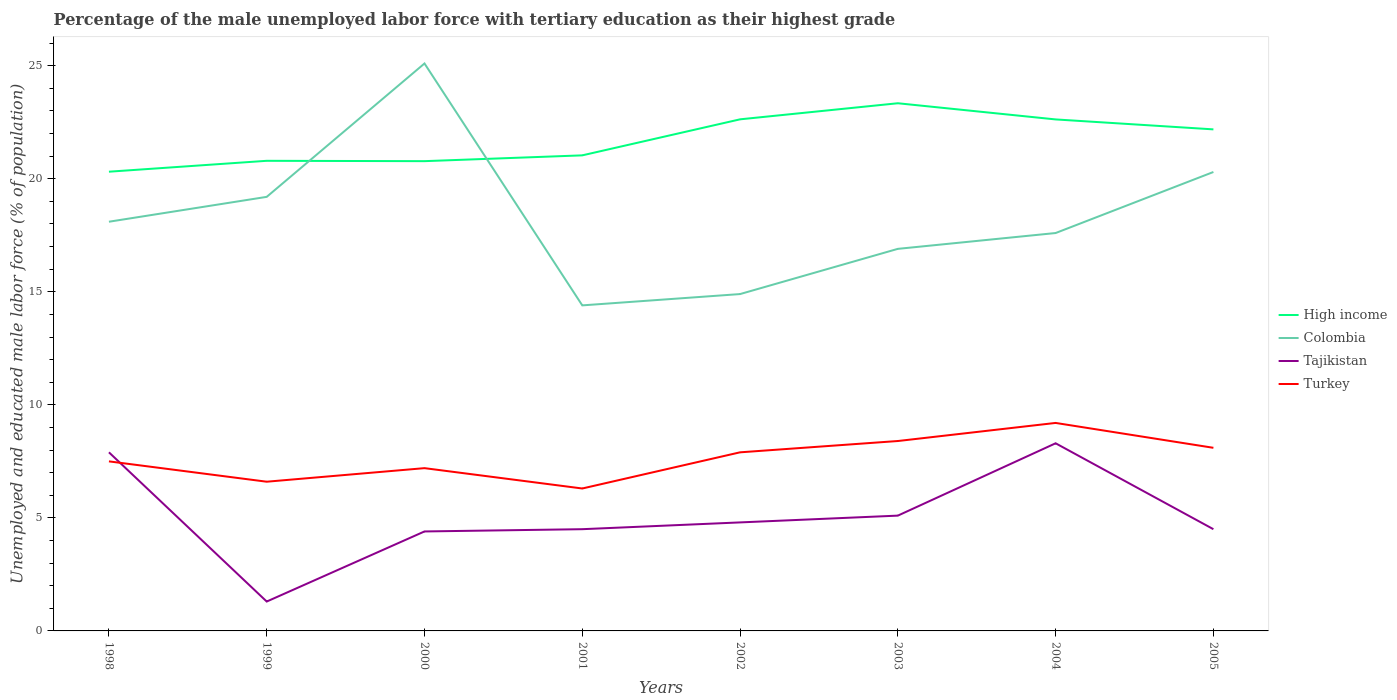How many different coloured lines are there?
Ensure brevity in your answer.  4. Does the line corresponding to Colombia intersect with the line corresponding to Turkey?
Ensure brevity in your answer.  No. Is the number of lines equal to the number of legend labels?
Offer a terse response. Yes. Across all years, what is the maximum percentage of the unemployed male labor force with tertiary education in Turkey?
Your answer should be very brief. 6.3. In which year was the percentage of the unemployed male labor force with tertiary education in High income maximum?
Your response must be concise. 1998. What is the total percentage of the unemployed male labor force with tertiary education in Colombia in the graph?
Keep it short and to the point. 0.5. What is the difference between the highest and the second highest percentage of the unemployed male labor force with tertiary education in Turkey?
Offer a very short reply. 2.9. What is the difference between the highest and the lowest percentage of the unemployed male labor force with tertiary education in Colombia?
Provide a short and direct response. 3. Is the percentage of the unemployed male labor force with tertiary education in High income strictly greater than the percentage of the unemployed male labor force with tertiary education in Colombia over the years?
Offer a terse response. No. How many lines are there?
Provide a short and direct response. 4. Does the graph contain any zero values?
Your response must be concise. No. Does the graph contain grids?
Your response must be concise. No. What is the title of the graph?
Give a very brief answer. Percentage of the male unemployed labor force with tertiary education as their highest grade. What is the label or title of the Y-axis?
Your answer should be compact. Unemployed and educated male labor force (% of population). What is the Unemployed and educated male labor force (% of population) in High income in 1998?
Make the answer very short. 20.31. What is the Unemployed and educated male labor force (% of population) of Colombia in 1998?
Offer a terse response. 18.1. What is the Unemployed and educated male labor force (% of population) of Tajikistan in 1998?
Offer a very short reply. 7.9. What is the Unemployed and educated male labor force (% of population) of High income in 1999?
Provide a succinct answer. 20.79. What is the Unemployed and educated male labor force (% of population) of Colombia in 1999?
Ensure brevity in your answer.  19.2. What is the Unemployed and educated male labor force (% of population) of Tajikistan in 1999?
Your response must be concise. 1.3. What is the Unemployed and educated male labor force (% of population) in Turkey in 1999?
Your answer should be very brief. 6.6. What is the Unemployed and educated male labor force (% of population) in High income in 2000?
Offer a terse response. 20.78. What is the Unemployed and educated male labor force (% of population) in Colombia in 2000?
Offer a terse response. 25.1. What is the Unemployed and educated male labor force (% of population) of Tajikistan in 2000?
Keep it short and to the point. 4.4. What is the Unemployed and educated male labor force (% of population) in Turkey in 2000?
Keep it short and to the point. 7.2. What is the Unemployed and educated male labor force (% of population) of High income in 2001?
Offer a terse response. 21.04. What is the Unemployed and educated male labor force (% of population) in Colombia in 2001?
Keep it short and to the point. 14.4. What is the Unemployed and educated male labor force (% of population) of Turkey in 2001?
Offer a very short reply. 6.3. What is the Unemployed and educated male labor force (% of population) of High income in 2002?
Your answer should be very brief. 22.63. What is the Unemployed and educated male labor force (% of population) of Colombia in 2002?
Give a very brief answer. 14.9. What is the Unemployed and educated male labor force (% of population) in Tajikistan in 2002?
Offer a terse response. 4.8. What is the Unemployed and educated male labor force (% of population) of Turkey in 2002?
Give a very brief answer. 7.9. What is the Unemployed and educated male labor force (% of population) of High income in 2003?
Your answer should be compact. 23.34. What is the Unemployed and educated male labor force (% of population) in Colombia in 2003?
Provide a short and direct response. 16.9. What is the Unemployed and educated male labor force (% of population) of Tajikistan in 2003?
Your response must be concise. 5.1. What is the Unemployed and educated male labor force (% of population) in Turkey in 2003?
Make the answer very short. 8.4. What is the Unemployed and educated male labor force (% of population) in High income in 2004?
Provide a short and direct response. 22.63. What is the Unemployed and educated male labor force (% of population) in Colombia in 2004?
Provide a short and direct response. 17.6. What is the Unemployed and educated male labor force (% of population) in Tajikistan in 2004?
Provide a short and direct response. 8.3. What is the Unemployed and educated male labor force (% of population) in Turkey in 2004?
Offer a terse response. 9.2. What is the Unemployed and educated male labor force (% of population) in High income in 2005?
Keep it short and to the point. 22.19. What is the Unemployed and educated male labor force (% of population) in Colombia in 2005?
Your response must be concise. 20.3. What is the Unemployed and educated male labor force (% of population) in Turkey in 2005?
Provide a short and direct response. 8.1. Across all years, what is the maximum Unemployed and educated male labor force (% of population) in High income?
Offer a very short reply. 23.34. Across all years, what is the maximum Unemployed and educated male labor force (% of population) of Colombia?
Make the answer very short. 25.1. Across all years, what is the maximum Unemployed and educated male labor force (% of population) in Tajikistan?
Offer a terse response. 8.3. Across all years, what is the maximum Unemployed and educated male labor force (% of population) of Turkey?
Ensure brevity in your answer.  9.2. Across all years, what is the minimum Unemployed and educated male labor force (% of population) of High income?
Offer a very short reply. 20.31. Across all years, what is the minimum Unemployed and educated male labor force (% of population) in Colombia?
Provide a short and direct response. 14.4. Across all years, what is the minimum Unemployed and educated male labor force (% of population) in Tajikistan?
Provide a succinct answer. 1.3. Across all years, what is the minimum Unemployed and educated male labor force (% of population) in Turkey?
Your answer should be very brief. 6.3. What is the total Unemployed and educated male labor force (% of population) of High income in the graph?
Your answer should be very brief. 173.7. What is the total Unemployed and educated male labor force (% of population) in Colombia in the graph?
Offer a terse response. 146.5. What is the total Unemployed and educated male labor force (% of population) in Tajikistan in the graph?
Offer a terse response. 40.8. What is the total Unemployed and educated male labor force (% of population) in Turkey in the graph?
Keep it short and to the point. 61.2. What is the difference between the Unemployed and educated male labor force (% of population) in High income in 1998 and that in 1999?
Make the answer very short. -0.48. What is the difference between the Unemployed and educated male labor force (% of population) in Colombia in 1998 and that in 1999?
Offer a terse response. -1.1. What is the difference between the Unemployed and educated male labor force (% of population) of High income in 1998 and that in 2000?
Keep it short and to the point. -0.47. What is the difference between the Unemployed and educated male labor force (% of population) in Colombia in 1998 and that in 2000?
Provide a succinct answer. -7. What is the difference between the Unemployed and educated male labor force (% of population) of High income in 1998 and that in 2001?
Provide a short and direct response. -0.72. What is the difference between the Unemployed and educated male labor force (% of population) in Colombia in 1998 and that in 2001?
Your answer should be compact. 3.7. What is the difference between the Unemployed and educated male labor force (% of population) in Tajikistan in 1998 and that in 2001?
Offer a terse response. 3.4. What is the difference between the Unemployed and educated male labor force (% of population) in High income in 1998 and that in 2002?
Your answer should be very brief. -2.32. What is the difference between the Unemployed and educated male labor force (% of population) of Colombia in 1998 and that in 2002?
Provide a succinct answer. 3.2. What is the difference between the Unemployed and educated male labor force (% of population) in Turkey in 1998 and that in 2002?
Offer a terse response. -0.4. What is the difference between the Unemployed and educated male labor force (% of population) of High income in 1998 and that in 2003?
Ensure brevity in your answer.  -3.03. What is the difference between the Unemployed and educated male labor force (% of population) of Tajikistan in 1998 and that in 2003?
Make the answer very short. 2.8. What is the difference between the Unemployed and educated male labor force (% of population) in Turkey in 1998 and that in 2003?
Your answer should be compact. -0.9. What is the difference between the Unemployed and educated male labor force (% of population) of High income in 1998 and that in 2004?
Your answer should be compact. -2.31. What is the difference between the Unemployed and educated male labor force (% of population) in High income in 1998 and that in 2005?
Offer a terse response. -1.87. What is the difference between the Unemployed and educated male labor force (% of population) of High income in 1999 and that in 2000?
Give a very brief answer. 0.02. What is the difference between the Unemployed and educated male labor force (% of population) of Colombia in 1999 and that in 2000?
Make the answer very short. -5.9. What is the difference between the Unemployed and educated male labor force (% of population) of Turkey in 1999 and that in 2000?
Provide a succinct answer. -0.6. What is the difference between the Unemployed and educated male labor force (% of population) in High income in 1999 and that in 2001?
Offer a very short reply. -0.24. What is the difference between the Unemployed and educated male labor force (% of population) of High income in 1999 and that in 2002?
Give a very brief answer. -1.83. What is the difference between the Unemployed and educated male labor force (% of population) in Colombia in 1999 and that in 2002?
Provide a short and direct response. 4.3. What is the difference between the Unemployed and educated male labor force (% of population) in High income in 1999 and that in 2003?
Your answer should be compact. -2.55. What is the difference between the Unemployed and educated male labor force (% of population) in Turkey in 1999 and that in 2003?
Give a very brief answer. -1.8. What is the difference between the Unemployed and educated male labor force (% of population) of High income in 1999 and that in 2004?
Ensure brevity in your answer.  -1.83. What is the difference between the Unemployed and educated male labor force (% of population) of Colombia in 1999 and that in 2004?
Ensure brevity in your answer.  1.6. What is the difference between the Unemployed and educated male labor force (% of population) in Tajikistan in 1999 and that in 2004?
Give a very brief answer. -7. What is the difference between the Unemployed and educated male labor force (% of population) in Turkey in 1999 and that in 2004?
Ensure brevity in your answer.  -2.6. What is the difference between the Unemployed and educated male labor force (% of population) in High income in 1999 and that in 2005?
Offer a very short reply. -1.39. What is the difference between the Unemployed and educated male labor force (% of population) in Tajikistan in 1999 and that in 2005?
Provide a short and direct response. -3.2. What is the difference between the Unemployed and educated male labor force (% of population) in High income in 2000 and that in 2001?
Provide a short and direct response. -0.26. What is the difference between the Unemployed and educated male labor force (% of population) in Tajikistan in 2000 and that in 2001?
Your response must be concise. -0.1. What is the difference between the Unemployed and educated male labor force (% of population) in High income in 2000 and that in 2002?
Give a very brief answer. -1.85. What is the difference between the Unemployed and educated male labor force (% of population) of Colombia in 2000 and that in 2002?
Provide a short and direct response. 10.2. What is the difference between the Unemployed and educated male labor force (% of population) of Tajikistan in 2000 and that in 2002?
Give a very brief answer. -0.4. What is the difference between the Unemployed and educated male labor force (% of population) in High income in 2000 and that in 2003?
Make the answer very short. -2.56. What is the difference between the Unemployed and educated male labor force (% of population) in Colombia in 2000 and that in 2003?
Provide a short and direct response. 8.2. What is the difference between the Unemployed and educated male labor force (% of population) in High income in 2000 and that in 2004?
Your answer should be compact. -1.85. What is the difference between the Unemployed and educated male labor force (% of population) of High income in 2000 and that in 2005?
Your answer should be compact. -1.41. What is the difference between the Unemployed and educated male labor force (% of population) of Colombia in 2000 and that in 2005?
Make the answer very short. 4.8. What is the difference between the Unemployed and educated male labor force (% of population) of Tajikistan in 2000 and that in 2005?
Offer a very short reply. -0.1. What is the difference between the Unemployed and educated male labor force (% of population) in Turkey in 2000 and that in 2005?
Your answer should be very brief. -0.9. What is the difference between the Unemployed and educated male labor force (% of population) in High income in 2001 and that in 2002?
Offer a very short reply. -1.59. What is the difference between the Unemployed and educated male labor force (% of population) in Tajikistan in 2001 and that in 2002?
Make the answer very short. -0.3. What is the difference between the Unemployed and educated male labor force (% of population) of High income in 2001 and that in 2003?
Give a very brief answer. -2.3. What is the difference between the Unemployed and educated male labor force (% of population) of Tajikistan in 2001 and that in 2003?
Make the answer very short. -0.6. What is the difference between the Unemployed and educated male labor force (% of population) of High income in 2001 and that in 2004?
Your answer should be very brief. -1.59. What is the difference between the Unemployed and educated male labor force (% of population) of Colombia in 2001 and that in 2004?
Keep it short and to the point. -3.2. What is the difference between the Unemployed and educated male labor force (% of population) in Tajikistan in 2001 and that in 2004?
Give a very brief answer. -3.8. What is the difference between the Unemployed and educated male labor force (% of population) of High income in 2001 and that in 2005?
Make the answer very short. -1.15. What is the difference between the Unemployed and educated male labor force (% of population) in Tajikistan in 2001 and that in 2005?
Offer a very short reply. 0. What is the difference between the Unemployed and educated male labor force (% of population) in High income in 2002 and that in 2003?
Give a very brief answer. -0.71. What is the difference between the Unemployed and educated male labor force (% of population) in High income in 2002 and that in 2004?
Your answer should be very brief. 0. What is the difference between the Unemployed and educated male labor force (% of population) in Colombia in 2002 and that in 2004?
Offer a very short reply. -2.7. What is the difference between the Unemployed and educated male labor force (% of population) of Tajikistan in 2002 and that in 2004?
Your answer should be very brief. -3.5. What is the difference between the Unemployed and educated male labor force (% of population) of High income in 2002 and that in 2005?
Offer a terse response. 0.44. What is the difference between the Unemployed and educated male labor force (% of population) of Tajikistan in 2002 and that in 2005?
Make the answer very short. 0.3. What is the difference between the Unemployed and educated male labor force (% of population) in Turkey in 2002 and that in 2005?
Offer a very short reply. -0.2. What is the difference between the Unemployed and educated male labor force (% of population) of High income in 2003 and that in 2004?
Ensure brevity in your answer.  0.72. What is the difference between the Unemployed and educated male labor force (% of population) of Tajikistan in 2003 and that in 2004?
Provide a short and direct response. -3.2. What is the difference between the Unemployed and educated male labor force (% of population) in High income in 2003 and that in 2005?
Offer a very short reply. 1.16. What is the difference between the Unemployed and educated male labor force (% of population) in Colombia in 2003 and that in 2005?
Provide a succinct answer. -3.4. What is the difference between the Unemployed and educated male labor force (% of population) in High income in 2004 and that in 2005?
Provide a succinct answer. 0.44. What is the difference between the Unemployed and educated male labor force (% of population) in Tajikistan in 2004 and that in 2005?
Ensure brevity in your answer.  3.8. What is the difference between the Unemployed and educated male labor force (% of population) in Turkey in 2004 and that in 2005?
Your answer should be very brief. 1.1. What is the difference between the Unemployed and educated male labor force (% of population) of High income in 1998 and the Unemployed and educated male labor force (% of population) of Colombia in 1999?
Give a very brief answer. 1.11. What is the difference between the Unemployed and educated male labor force (% of population) in High income in 1998 and the Unemployed and educated male labor force (% of population) in Tajikistan in 1999?
Your response must be concise. 19.01. What is the difference between the Unemployed and educated male labor force (% of population) in High income in 1998 and the Unemployed and educated male labor force (% of population) in Turkey in 1999?
Provide a short and direct response. 13.71. What is the difference between the Unemployed and educated male labor force (% of population) of High income in 1998 and the Unemployed and educated male labor force (% of population) of Colombia in 2000?
Offer a terse response. -4.79. What is the difference between the Unemployed and educated male labor force (% of population) of High income in 1998 and the Unemployed and educated male labor force (% of population) of Tajikistan in 2000?
Your answer should be very brief. 15.91. What is the difference between the Unemployed and educated male labor force (% of population) in High income in 1998 and the Unemployed and educated male labor force (% of population) in Turkey in 2000?
Ensure brevity in your answer.  13.11. What is the difference between the Unemployed and educated male labor force (% of population) of High income in 1998 and the Unemployed and educated male labor force (% of population) of Colombia in 2001?
Your answer should be very brief. 5.91. What is the difference between the Unemployed and educated male labor force (% of population) in High income in 1998 and the Unemployed and educated male labor force (% of population) in Tajikistan in 2001?
Make the answer very short. 15.81. What is the difference between the Unemployed and educated male labor force (% of population) of High income in 1998 and the Unemployed and educated male labor force (% of population) of Turkey in 2001?
Provide a succinct answer. 14.01. What is the difference between the Unemployed and educated male labor force (% of population) of Tajikistan in 1998 and the Unemployed and educated male labor force (% of population) of Turkey in 2001?
Provide a succinct answer. 1.6. What is the difference between the Unemployed and educated male labor force (% of population) of High income in 1998 and the Unemployed and educated male labor force (% of population) of Colombia in 2002?
Keep it short and to the point. 5.41. What is the difference between the Unemployed and educated male labor force (% of population) of High income in 1998 and the Unemployed and educated male labor force (% of population) of Tajikistan in 2002?
Offer a terse response. 15.51. What is the difference between the Unemployed and educated male labor force (% of population) of High income in 1998 and the Unemployed and educated male labor force (% of population) of Turkey in 2002?
Your response must be concise. 12.41. What is the difference between the Unemployed and educated male labor force (% of population) in Colombia in 1998 and the Unemployed and educated male labor force (% of population) in Tajikistan in 2002?
Give a very brief answer. 13.3. What is the difference between the Unemployed and educated male labor force (% of population) of Colombia in 1998 and the Unemployed and educated male labor force (% of population) of Turkey in 2002?
Your answer should be very brief. 10.2. What is the difference between the Unemployed and educated male labor force (% of population) of Tajikistan in 1998 and the Unemployed and educated male labor force (% of population) of Turkey in 2002?
Offer a terse response. 0. What is the difference between the Unemployed and educated male labor force (% of population) in High income in 1998 and the Unemployed and educated male labor force (% of population) in Colombia in 2003?
Offer a very short reply. 3.41. What is the difference between the Unemployed and educated male labor force (% of population) of High income in 1998 and the Unemployed and educated male labor force (% of population) of Tajikistan in 2003?
Provide a succinct answer. 15.21. What is the difference between the Unemployed and educated male labor force (% of population) in High income in 1998 and the Unemployed and educated male labor force (% of population) in Turkey in 2003?
Make the answer very short. 11.91. What is the difference between the Unemployed and educated male labor force (% of population) of Colombia in 1998 and the Unemployed and educated male labor force (% of population) of Turkey in 2003?
Your answer should be compact. 9.7. What is the difference between the Unemployed and educated male labor force (% of population) of Tajikistan in 1998 and the Unemployed and educated male labor force (% of population) of Turkey in 2003?
Make the answer very short. -0.5. What is the difference between the Unemployed and educated male labor force (% of population) in High income in 1998 and the Unemployed and educated male labor force (% of population) in Colombia in 2004?
Offer a terse response. 2.71. What is the difference between the Unemployed and educated male labor force (% of population) of High income in 1998 and the Unemployed and educated male labor force (% of population) of Tajikistan in 2004?
Offer a terse response. 12.01. What is the difference between the Unemployed and educated male labor force (% of population) of High income in 1998 and the Unemployed and educated male labor force (% of population) of Turkey in 2004?
Provide a succinct answer. 11.11. What is the difference between the Unemployed and educated male labor force (% of population) in Colombia in 1998 and the Unemployed and educated male labor force (% of population) in Tajikistan in 2004?
Provide a succinct answer. 9.8. What is the difference between the Unemployed and educated male labor force (% of population) in High income in 1998 and the Unemployed and educated male labor force (% of population) in Colombia in 2005?
Your answer should be compact. 0.01. What is the difference between the Unemployed and educated male labor force (% of population) in High income in 1998 and the Unemployed and educated male labor force (% of population) in Tajikistan in 2005?
Your response must be concise. 15.81. What is the difference between the Unemployed and educated male labor force (% of population) in High income in 1998 and the Unemployed and educated male labor force (% of population) in Turkey in 2005?
Your response must be concise. 12.21. What is the difference between the Unemployed and educated male labor force (% of population) in Colombia in 1998 and the Unemployed and educated male labor force (% of population) in Tajikistan in 2005?
Your answer should be very brief. 13.6. What is the difference between the Unemployed and educated male labor force (% of population) in Colombia in 1998 and the Unemployed and educated male labor force (% of population) in Turkey in 2005?
Give a very brief answer. 10. What is the difference between the Unemployed and educated male labor force (% of population) in High income in 1999 and the Unemployed and educated male labor force (% of population) in Colombia in 2000?
Your answer should be very brief. -4.31. What is the difference between the Unemployed and educated male labor force (% of population) in High income in 1999 and the Unemployed and educated male labor force (% of population) in Tajikistan in 2000?
Give a very brief answer. 16.39. What is the difference between the Unemployed and educated male labor force (% of population) of High income in 1999 and the Unemployed and educated male labor force (% of population) of Turkey in 2000?
Provide a succinct answer. 13.59. What is the difference between the Unemployed and educated male labor force (% of population) in Colombia in 1999 and the Unemployed and educated male labor force (% of population) in Tajikistan in 2000?
Provide a short and direct response. 14.8. What is the difference between the Unemployed and educated male labor force (% of population) in Tajikistan in 1999 and the Unemployed and educated male labor force (% of population) in Turkey in 2000?
Keep it short and to the point. -5.9. What is the difference between the Unemployed and educated male labor force (% of population) of High income in 1999 and the Unemployed and educated male labor force (% of population) of Colombia in 2001?
Your answer should be compact. 6.39. What is the difference between the Unemployed and educated male labor force (% of population) in High income in 1999 and the Unemployed and educated male labor force (% of population) in Tajikistan in 2001?
Your response must be concise. 16.29. What is the difference between the Unemployed and educated male labor force (% of population) of High income in 1999 and the Unemployed and educated male labor force (% of population) of Turkey in 2001?
Your answer should be compact. 14.49. What is the difference between the Unemployed and educated male labor force (% of population) of High income in 1999 and the Unemployed and educated male labor force (% of population) of Colombia in 2002?
Offer a terse response. 5.89. What is the difference between the Unemployed and educated male labor force (% of population) in High income in 1999 and the Unemployed and educated male labor force (% of population) in Tajikistan in 2002?
Your answer should be very brief. 15.99. What is the difference between the Unemployed and educated male labor force (% of population) of High income in 1999 and the Unemployed and educated male labor force (% of population) of Turkey in 2002?
Your response must be concise. 12.89. What is the difference between the Unemployed and educated male labor force (% of population) of Colombia in 1999 and the Unemployed and educated male labor force (% of population) of Turkey in 2002?
Offer a very short reply. 11.3. What is the difference between the Unemployed and educated male labor force (% of population) of Tajikistan in 1999 and the Unemployed and educated male labor force (% of population) of Turkey in 2002?
Your answer should be compact. -6.6. What is the difference between the Unemployed and educated male labor force (% of population) in High income in 1999 and the Unemployed and educated male labor force (% of population) in Colombia in 2003?
Your answer should be very brief. 3.89. What is the difference between the Unemployed and educated male labor force (% of population) in High income in 1999 and the Unemployed and educated male labor force (% of population) in Tajikistan in 2003?
Give a very brief answer. 15.69. What is the difference between the Unemployed and educated male labor force (% of population) in High income in 1999 and the Unemployed and educated male labor force (% of population) in Turkey in 2003?
Give a very brief answer. 12.39. What is the difference between the Unemployed and educated male labor force (% of population) in Colombia in 1999 and the Unemployed and educated male labor force (% of population) in Tajikistan in 2003?
Offer a very short reply. 14.1. What is the difference between the Unemployed and educated male labor force (% of population) of Colombia in 1999 and the Unemployed and educated male labor force (% of population) of Turkey in 2003?
Your response must be concise. 10.8. What is the difference between the Unemployed and educated male labor force (% of population) of Tajikistan in 1999 and the Unemployed and educated male labor force (% of population) of Turkey in 2003?
Your response must be concise. -7.1. What is the difference between the Unemployed and educated male labor force (% of population) in High income in 1999 and the Unemployed and educated male labor force (% of population) in Colombia in 2004?
Your response must be concise. 3.19. What is the difference between the Unemployed and educated male labor force (% of population) in High income in 1999 and the Unemployed and educated male labor force (% of population) in Tajikistan in 2004?
Your answer should be compact. 12.49. What is the difference between the Unemployed and educated male labor force (% of population) in High income in 1999 and the Unemployed and educated male labor force (% of population) in Turkey in 2004?
Offer a terse response. 11.59. What is the difference between the Unemployed and educated male labor force (% of population) of Colombia in 1999 and the Unemployed and educated male labor force (% of population) of Tajikistan in 2004?
Your answer should be compact. 10.9. What is the difference between the Unemployed and educated male labor force (% of population) in Colombia in 1999 and the Unemployed and educated male labor force (% of population) in Turkey in 2004?
Your response must be concise. 10. What is the difference between the Unemployed and educated male labor force (% of population) of High income in 1999 and the Unemployed and educated male labor force (% of population) of Colombia in 2005?
Provide a succinct answer. 0.49. What is the difference between the Unemployed and educated male labor force (% of population) in High income in 1999 and the Unemployed and educated male labor force (% of population) in Tajikistan in 2005?
Your response must be concise. 16.29. What is the difference between the Unemployed and educated male labor force (% of population) of High income in 1999 and the Unemployed and educated male labor force (% of population) of Turkey in 2005?
Provide a short and direct response. 12.69. What is the difference between the Unemployed and educated male labor force (% of population) in Colombia in 1999 and the Unemployed and educated male labor force (% of population) in Tajikistan in 2005?
Give a very brief answer. 14.7. What is the difference between the Unemployed and educated male labor force (% of population) of High income in 2000 and the Unemployed and educated male labor force (% of population) of Colombia in 2001?
Offer a very short reply. 6.38. What is the difference between the Unemployed and educated male labor force (% of population) in High income in 2000 and the Unemployed and educated male labor force (% of population) in Tajikistan in 2001?
Offer a terse response. 16.28. What is the difference between the Unemployed and educated male labor force (% of population) in High income in 2000 and the Unemployed and educated male labor force (% of population) in Turkey in 2001?
Give a very brief answer. 14.48. What is the difference between the Unemployed and educated male labor force (% of population) in Colombia in 2000 and the Unemployed and educated male labor force (% of population) in Tajikistan in 2001?
Your answer should be very brief. 20.6. What is the difference between the Unemployed and educated male labor force (% of population) of Colombia in 2000 and the Unemployed and educated male labor force (% of population) of Turkey in 2001?
Ensure brevity in your answer.  18.8. What is the difference between the Unemployed and educated male labor force (% of population) of Tajikistan in 2000 and the Unemployed and educated male labor force (% of population) of Turkey in 2001?
Your response must be concise. -1.9. What is the difference between the Unemployed and educated male labor force (% of population) in High income in 2000 and the Unemployed and educated male labor force (% of population) in Colombia in 2002?
Ensure brevity in your answer.  5.88. What is the difference between the Unemployed and educated male labor force (% of population) in High income in 2000 and the Unemployed and educated male labor force (% of population) in Tajikistan in 2002?
Your answer should be compact. 15.98. What is the difference between the Unemployed and educated male labor force (% of population) of High income in 2000 and the Unemployed and educated male labor force (% of population) of Turkey in 2002?
Your response must be concise. 12.88. What is the difference between the Unemployed and educated male labor force (% of population) in Colombia in 2000 and the Unemployed and educated male labor force (% of population) in Tajikistan in 2002?
Provide a succinct answer. 20.3. What is the difference between the Unemployed and educated male labor force (% of population) in High income in 2000 and the Unemployed and educated male labor force (% of population) in Colombia in 2003?
Give a very brief answer. 3.88. What is the difference between the Unemployed and educated male labor force (% of population) in High income in 2000 and the Unemployed and educated male labor force (% of population) in Tajikistan in 2003?
Provide a succinct answer. 15.68. What is the difference between the Unemployed and educated male labor force (% of population) in High income in 2000 and the Unemployed and educated male labor force (% of population) in Turkey in 2003?
Give a very brief answer. 12.38. What is the difference between the Unemployed and educated male labor force (% of population) of Colombia in 2000 and the Unemployed and educated male labor force (% of population) of Tajikistan in 2003?
Your answer should be compact. 20. What is the difference between the Unemployed and educated male labor force (% of population) of Colombia in 2000 and the Unemployed and educated male labor force (% of population) of Turkey in 2003?
Your answer should be very brief. 16.7. What is the difference between the Unemployed and educated male labor force (% of population) of High income in 2000 and the Unemployed and educated male labor force (% of population) of Colombia in 2004?
Your response must be concise. 3.18. What is the difference between the Unemployed and educated male labor force (% of population) in High income in 2000 and the Unemployed and educated male labor force (% of population) in Tajikistan in 2004?
Your answer should be very brief. 12.48. What is the difference between the Unemployed and educated male labor force (% of population) in High income in 2000 and the Unemployed and educated male labor force (% of population) in Turkey in 2004?
Give a very brief answer. 11.58. What is the difference between the Unemployed and educated male labor force (% of population) of Colombia in 2000 and the Unemployed and educated male labor force (% of population) of Tajikistan in 2004?
Your response must be concise. 16.8. What is the difference between the Unemployed and educated male labor force (% of population) in Colombia in 2000 and the Unemployed and educated male labor force (% of population) in Turkey in 2004?
Your answer should be compact. 15.9. What is the difference between the Unemployed and educated male labor force (% of population) of High income in 2000 and the Unemployed and educated male labor force (% of population) of Colombia in 2005?
Offer a very short reply. 0.48. What is the difference between the Unemployed and educated male labor force (% of population) of High income in 2000 and the Unemployed and educated male labor force (% of population) of Tajikistan in 2005?
Keep it short and to the point. 16.28. What is the difference between the Unemployed and educated male labor force (% of population) of High income in 2000 and the Unemployed and educated male labor force (% of population) of Turkey in 2005?
Your response must be concise. 12.68. What is the difference between the Unemployed and educated male labor force (% of population) in Colombia in 2000 and the Unemployed and educated male labor force (% of population) in Tajikistan in 2005?
Your answer should be very brief. 20.6. What is the difference between the Unemployed and educated male labor force (% of population) of Colombia in 2000 and the Unemployed and educated male labor force (% of population) of Turkey in 2005?
Your response must be concise. 17. What is the difference between the Unemployed and educated male labor force (% of population) in Tajikistan in 2000 and the Unemployed and educated male labor force (% of population) in Turkey in 2005?
Ensure brevity in your answer.  -3.7. What is the difference between the Unemployed and educated male labor force (% of population) in High income in 2001 and the Unemployed and educated male labor force (% of population) in Colombia in 2002?
Give a very brief answer. 6.14. What is the difference between the Unemployed and educated male labor force (% of population) of High income in 2001 and the Unemployed and educated male labor force (% of population) of Tajikistan in 2002?
Your answer should be compact. 16.24. What is the difference between the Unemployed and educated male labor force (% of population) of High income in 2001 and the Unemployed and educated male labor force (% of population) of Turkey in 2002?
Provide a succinct answer. 13.14. What is the difference between the Unemployed and educated male labor force (% of population) of High income in 2001 and the Unemployed and educated male labor force (% of population) of Colombia in 2003?
Provide a succinct answer. 4.14. What is the difference between the Unemployed and educated male labor force (% of population) of High income in 2001 and the Unemployed and educated male labor force (% of population) of Tajikistan in 2003?
Your answer should be compact. 15.94. What is the difference between the Unemployed and educated male labor force (% of population) of High income in 2001 and the Unemployed and educated male labor force (% of population) of Turkey in 2003?
Your answer should be very brief. 12.64. What is the difference between the Unemployed and educated male labor force (% of population) in Colombia in 2001 and the Unemployed and educated male labor force (% of population) in Turkey in 2003?
Your response must be concise. 6. What is the difference between the Unemployed and educated male labor force (% of population) of Tajikistan in 2001 and the Unemployed and educated male labor force (% of population) of Turkey in 2003?
Your response must be concise. -3.9. What is the difference between the Unemployed and educated male labor force (% of population) in High income in 2001 and the Unemployed and educated male labor force (% of population) in Colombia in 2004?
Make the answer very short. 3.44. What is the difference between the Unemployed and educated male labor force (% of population) in High income in 2001 and the Unemployed and educated male labor force (% of population) in Tajikistan in 2004?
Offer a terse response. 12.74. What is the difference between the Unemployed and educated male labor force (% of population) in High income in 2001 and the Unemployed and educated male labor force (% of population) in Turkey in 2004?
Offer a terse response. 11.84. What is the difference between the Unemployed and educated male labor force (% of population) of High income in 2001 and the Unemployed and educated male labor force (% of population) of Colombia in 2005?
Your answer should be very brief. 0.74. What is the difference between the Unemployed and educated male labor force (% of population) of High income in 2001 and the Unemployed and educated male labor force (% of population) of Tajikistan in 2005?
Provide a short and direct response. 16.54. What is the difference between the Unemployed and educated male labor force (% of population) in High income in 2001 and the Unemployed and educated male labor force (% of population) in Turkey in 2005?
Offer a very short reply. 12.94. What is the difference between the Unemployed and educated male labor force (% of population) in Tajikistan in 2001 and the Unemployed and educated male labor force (% of population) in Turkey in 2005?
Offer a very short reply. -3.6. What is the difference between the Unemployed and educated male labor force (% of population) in High income in 2002 and the Unemployed and educated male labor force (% of population) in Colombia in 2003?
Give a very brief answer. 5.73. What is the difference between the Unemployed and educated male labor force (% of population) in High income in 2002 and the Unemployed and educated male labor force (% of population) in Tajikistan in 2003?
Offer a terse response. 17.53. What is the difference between the Unemployed and educated male labor force (% of population) of High income in 2002 and the Unemployed and educated male labor force (% of population) of Turkey in 2003?
Provide a short and direct response. 14.23. What is the difference between the Unemployed and educated male labor force (% of population) in Colombia in 2002 and the Unemployed and educated male labor force (% of population) in Turkey in 2003?
Provide a short and direct response. 6.5. What is the difference between the Unemployed and educated male labor force (% of population) of Tajikistan in 2002 and the Unemployed and educated male labor force (% of population) of Turkey in 2003?
Provide a short and direct response. -3.6. What is the difference between the Unemployed and educated male labor force (% of population) of High income in 2002 and the Unemployed and educated male labor force (% of population) of Colombia in 2004?
Make the answer very short. 5.03. What is the difference between the Unemployed and educated male labor force (% of population) of High income in 2002 and the Unemployed and educated male labor force (% of population) of Tajikistan in 2004?
Your answer should be very brief. 14.33. What is the difference between the Unemployed and educated male labor force (% of population) of High income in 2002 and the Unemployed and educated male labor force (% of population) of Turkey in 2004?
Ensure brevity in your answer.  13.43. What is the difference between the Unemployed and educated male labor force (% of population) of Colombia in 2002 and the Unemployed and educated male labor force (% of population) of Tajikistan in 2004?
Make the answer very short. 6.6. What is the difference between the Unemployed and educated male labor force (% of population) of Colombia in 2002 and the Unemployed and educated male labor force (% of population) of Turkey in 2004?
Your answer should be compact. 5.7. What is the difference between the Unemployed and educated male labor force (% of population) in High income in 2002 and the Unemployed and educated male labor force (% of population) in Colombia in 2005?
Offer a very short reply. 2.33. What is the difference between the Unemployed and educated male labor force (% of population) in High income in 2002 and the Unemployed and educated male labor force (% of population) in Tajikistan in 2005?
Offer a very short reply. 18.13. What is the difference between the Unemployed and educated male labor force (% of population) of High income in 2002 and the Unemployed and educated male labor force (% of population) of Turkey in 2005?
Provide a short and direct response. 14.53. What is the difference between the Unemployed and educated male labor force (% of population) of Colombia in 2002 and the Unemployed and educated male labor force (% of population) of Tajikistan in 2005?
Your answer should be very brief. 10.4. What is the difference between the Unemployed and educated male labor force (% of population) of High income in 2003 and the Unemployed and educated male labor force (% of population) of Colombia in 2004?
Provide a short and direct response. 5.74. What is the difference between the Unemployed and educated male labor force (% of population) in High income in 2003 and the Unemployed and educated male labor force (% of population) in Tajikistan in 2004?
Ensure brevity in your answer.  15.04. What is the difference between the Unemployed and educated male labor force (% of population) of High income in 2003 and the Unemployed and educated male labor force (% of population) of Turkey in 2004?
Offer a very short reply. 14.14. What is the difference between the Unemployed and educated male labor force (% of population) of Colombia in 2003 and the Unemployed and educated male labor force (% of population) of Tajikistan in 2004?
Keep it short and to the point. 8.6. What is the difference between the Unemployed and educated male labor force (% of population) in Colombia in 2003 and the Unemployed and educated male labor force (% of population) in Turkey in 2004?
Ensure brevity in your answer.  7.7. What is the difference between the Unemployed and educated male labor force (% of population) of High income in 2003 and the Unemployed and educated male labor force (% of population) of Colombia in 2005?
Your answer should be very brief. 3.04. What is the difference between the Unemployed and educated male labor force (% of population) in High income in 2003 and the Unemployed and educated male labor force (% of population) in Tajikistan in 2005?
Provide a succinct answer. 18.84. What is the difference between the Unemployed and educated male labor force (% of population) in High income in 2003 and the Unemployed and educated male labor force (% of population) in Turkey in 2005?
Ensure brevity in your answer.  15.24. What is the difference between the Unemployed and educated male labor force (% of population) of Colombia in 2003 and the Unemployed and educated male labor force (% of population) of Turkey in 2005?
Offer a terse response. 8.8. What is the difference between the Unemployed and educated male labor force (% of population) in Tajikistan in 2003 and the Unemployed and educated male labor force (% of population) in Turkey in 2005?
Offer a terse response. -3. What is the difference between the Unemployed and educated male labor force (% of population) of High income in 2004 and the Unemployed and educated male labor force (% of population) of Colombia in 2005?
Ensure brevity in your answer.  2.33. What is the difference between the Unemployed and educated male labor force (% of population) of High income in 2004 and the Unemployed and educated male labor force (% of population) of Tajikistan in 2005?
Offer a terse response. 18.13. What is the difference between the Unemployed and educated male labor force (% of population) of High income in 2004 and the Unemployed and educated male labor force (% of population) of Turkey in 2005?
Your answer should be compact. 14.53. What is the difference between the Unemployed and educated male labor force (% of population) in Tajikistan in 2004 and the Unemployed and educated male labor force (% of population) in Turkey in 2005?
Your answer should be very brief. 0.2. What is the average Unemployed and educated male labor force (% of population) of High income per year?
Offer a very short reply. 21.71. What is the average Unemployed and educated male labor force (% of population) of Colombia per year?
Ensure brevity in your answer.  18.31. What is the average Unemployed and educated male labor force (% of population) of Tajikistan per year?
Your response must be concise. 5.1. What is the average Unemployed and educated male labor force (% of population) in Turkey per year?
Your response must be concise. 7.65. In the year 1998, what is the difference between the Unemployed and educated male labor force (% of population) in High income and Unemployed and educated male labor force (% of population) in Colombia?
Make the answer very short. 2.21. In the year 1998, what is the difference between the Unemployed and educated male labor force (% of population) of High income and Unemployed and educated male labor force (% of population) of Tajikistan?
Keep it short and to the point. 12.41. In the year 1998, what is the difference between the Unemployed and educated male labor force (% of population) in High income and Unemployed and educated male labor force (% of population) in Turkey?
Make the answer very short. 12.81. In the year 1998, what is the difference between the Unemployed and educated male labor force (% of population) of Colombia and Unemployed and educated male labor force (% of population) of Turkey?
Give a very brief answer. 10.6. In the year 1999, what is the difference between the Unemployed and educated male labor force (% of population) of High income and Unemployed and educated male labor force (% of population) of Colombia?
Make the answer very short. 1.59. In the year 1999, what is the difference between the Unemployed and educated male labor force (% of population) in High income and Unemployed and educated male labor force (% of population) in Tajikistan?
Your answer should be very brief. 19.49. In the year 1999, what is the difference between the Unemployed and educated male labor force (% of population) in High income and Unemployed and educated male labor force (% of population) in Turkey?
Provide a short and direct response. 14.19. In the year 1999, what is the difference between the Unemployed and educated male labor force (% of population) in Colombia and Unemployed and educated male labor force (% of population) in Turkey?
Provide a succinct answer. 12.6. In the year 2000, what is the difference between the Unemployed and educated male labor force (% of population) in High income and Unemployed and educated male labor force (% of population) in Colombia?
Your answer should be very brief. -4.32. In the year 2000, what is the difference between the Unemployed and educated male labor force (% of population) in High income and Unemployed and educated male labor force (% of population) in Tajikistan?
Your answer should be very brief. 16.38. In the year 2000, what is the difference between the Unemployed and educated male labor force (% of population) of High income and Unemployed and educated male labor force (% of population) of Turkey?
Offer a terse response. 13.58. In the year 2000, what is the difference between the Unemployed and educated male labor force (% of population) of Colombia and Unemployed and educated male labor force (% of population) of Tajikistan?
Make the answer very short. 20.7. In the year 2001, what is the difference between the Unemployed and educated male labor force (% of population) in High income and Unemployed and educated male labor force (% of population) in Colombia?
Ensure brevity in your answer.  6.64. In the year 2001, what is the difference between the Unemployed and educated male labor force (% of population) in High income and Unemployed and educated male labor force (% of population) in Tajikistan?
Ensure brevity in your answer.  16.54. In the year 2001, what is the difference between the Unemployed and educated male labor force (% of population) in High income and Unemployed and educated male labor force (% of population) in Turkey?
Provide a short and direct response. 14.74. In the year 2002, what is the difference between the Unemployed and educated male labor force (% of population) in High income and Unemployed and educated male labor force (% of population) in Colombia?
Offer a terse response. 7.73. In the year 2002, what is the difference between the Unemployed and educated male labor force (% of population) of High income and Unemployed and educated male labor force (% of population) of Tajikistan?
Your response must be concise. 17.83. In the year 2002, what is the difference between the Unemployed and educated male labor force (% of population) in High income and Unemployed and educated male labor force (% of population) in Turkey?
Ensure brevity in your answer.  14.73. In the year 2002, what is the difference between the Unemployed and educated male labor force (% of population) in Colombia and Unemployed and educated male labor force (% of population) in Turkey?
Your answer should be very brief. 7. In the year 2002, what is the difference between the Unemployed and educated male labor force (% of population) in Tajikistan and Unemployed and educated male labor force (% of population) in Turkey?
Provide a succinct answer. -3.1. In the year 2003, what is the difference between the Unemployed and educated male labor force (% of population) in High income and Unemployed and educated male labor force (% of population) in Colombia?
Your answer should be compact. 6.44. In the year 2003, what is the difference between the Unemployed and educated male labor force (% of population) of High income and Unemployed and educated male labor force (% of population) of Tajikistan?
Keep it short and to the point. 18.24. In the year 2003, what is the difference between the Unemployed and educated male labor force (% of population) of High income and Unemployed and educated male labor force (% of population) of Turkey?
Provide a short and direct response. 14.94. In the year 2003, what is the difference between the Unemployed and educated male labor force (% of population) of Tajikistan and Unemployed and educated male labor force (% of population) of Turkey?
Your response must be concise. -3.3. In the year 2004, what is the difference between the Unemployed and educated male labor force (% of population) in High income and Unemployed and educated male labor force (% of population) in Colombia?
Ensure brevity in your answer.  5.03. In the year 2004, what is the difference between the Unemployed and educated male labor force (% of population) of High income and Unemployed and educated male labor force (% of population) of Tajikistan?
Keep it short and to the point. 14.33. In the year 2004, what is the difference between the Unemployed and educated male labor force (% of population) of High income and Unemployed and educated male labor force (% of population) of Turkey?
Provide a succinct answer. 13.43. In the year 2004, what is the difference between the Unemployed and educated male labor force (% of population) in Colombia and Unemployed and educated male labor force (% of population) in Turkey?
Offer a very short reply. 8.4. In the year 2005, what is the difference between the Unemployed and educated male labor force (% of population) of High income and Unemployed and educated male labor force (% of population) of Colombia?
Ensure brevity in your answer.  1.89. In the year 2005, what is the difference between the Unemployed and educated male labor force (% of population) in High income and Unemployed and educated male labor force (% of population) in Tajikistan?
Give a very brief answer. 17.68. In the year 2005, what is the difference between the Unemployed and educated male labor force (% of population) of High income and Unemployed and educated male labor force (% of population) of Turkey?
Ensure brevity in your answer.  14.09. In the year 2005, what is the difference between the Unemployed and educated male labor force (% of population) of Tajikistan and Unemployed and educated male labor force (% of population) of Turkey?
Your answer should be very brief. -3.6. What is the ratio of the Unemployed and educated male labor force (% of population) of High income in 1998 to that in 1999?
Keep it short and to the point. 0.98. What is the ratio of the Unemployed and educated male labor force (% of population) of Colombia in 1998 to that in 1999?
Provide a short and direct response. 0.94. What is the ratio of the Unemployed and educated male labor force (% of population) in Tajikistan in 1998 to that in 1999?
Offer a terse response. 6.08. What is the ratio of the Unemployed and educated male labor force (% of population) of Turkey in 1998 to that in 1999?
Give a very brief answer. 1.14. What is the ratio of the Unemployed and educated male labor force (% of population) in High income in 1998 to that in 2000?
Give a very brief answer. 0.98. What is the ratio of the Unemployed and educated male labor force (% of population) of Colombia in 1998 to that in 2000?
Make the answer very short. 0.72. What is the ratio of the Unemployed and educated male labor force (% of population) in Tajikistan in 1998 to that in 2000?
Offer a very short reply. 1.8. What is the ratio of the Unemployed and educated male labor force (% of population) in Turkey in 1998 to that in 2000?
Provide a succinct answer. 1.04. What is the ratio of the Unemployed and educated male labor force (% of population) in High income in 1998 to that in 2001?
Provide a succinct answer. 0.97. What is the ratio of the Unemployed and educated male labor force (% of population) of Colombia in 1998 to that in 2001?
Keep it short and to the point. 1.26. What is the ratio of the Unemployed and educated male labor force (% of population) in Tajikistan in 1998 to that in 2001?
Provide a short and direct response. 1.76. What is the ratio of the Unemployed and educated male labor force (% of population) of Turkey in 1998 to that in 2001?
Your response must be concise. 1.19. What is the ratio of the Unemployed and educated male labor force (% of population) in High income in 1998 to that in 2002?
Offer a terse response. 0.9. What is the ratio of the Unemployed and educated male labor force (% of population) of Colombia in 1998 to that in 2002?
Provide a succinct answer. 1.21. What is the ratio of the Unemployed and educated male labor force (% of population) in Tajikistan in 1998 to that in 2002?
Provide a short and direct response. 1.65. What is the ratio of the Unemployed and educated male labor force (% of population) of Turkey in 1998 to that in 2002?
Keep it short and to the point. 0.95. What is the ratio of the Unemployed and educated male labor force (% of population) in High income in 1998 to that in 2003?
Offer a very short reply. 0.87. What is the ratio of the Unemployed and educated male labor force (% of population) in Colombia in 1998 to that in 2003?
Offer a very short reply. 1.07. What is the ratio of the Unemployed and educated male labor force (% of population) in Tajikistan in 1998 to that in 2003?
Provide a succinct answer. 1.55. What is the ratio of the Unemployed and educated male labor force (% of population) in Turkey in 1998 to that in 2003?
Offer a terse response. 0.89. What is the ratio of the Unemployed and educated male labor force (% of population) of High income in 1998 to that in 2004?
Make the answer very short. 0.9. What is the ratio of the Unemployed and educated male labor force (% of population) in Colombia in 1998 to that in 2004?
Provide a succinct answer. 1.03. What is the ratio of the Unemployed and educated male labor force (% of population) of Tajikistan in 1998 to that in 2004?
Your response must be concise. 0.95. What is the ratio of the Unemployed and educated male labor force (% of population) of Turkey in 1998 to that in 2004?
Your response must be concise. 0.82. What is the ratio of the Unemployed and educated male labor force (% of population) in High income in 1998 to that in 2005?
Keep it short and to the point. 0.92. What is the ratio of the Unemployed and educated male labor force (% of population) of Colombia in 1998 to that in 2005?
Make the answer very short. 0.89. What is the ratio of the Unemployed and educated male labor force (% of population) in Tajikistan in 1998 to that in 2005?
Offer a terse response. 1.76. What is the ratio of the Unemployed and educated male labor force (% of population) in Turkey in 1998 to that in 2005?
Your answer should be very brief. 0.93. What is the ratio of the Unemployed and educated male labor force (% of population) of High income in 1999 to that in 2000?
Your answer should be compact. 1. What is the ratio of the Unemployed and educated male labor force (% of population) of Colombia in 1999 to that in 2000?
Keep it short and to the point. 0.76. What is the ratio of the Unemployed and educated male labor force (% of population) in Tajikistan in 1999 to that in 2000?
Offer a terse response. 0.3. What is the ratio of the Unemployed and educated male labor force (% of population) of Turkey in 1999 to that in 2000?
Your response must be concise. 0.92. What is the ratio of the Unemployed and educated male labor force (% of population) of High income in 1999 to that in 2001?
Your answer should be very brief. 0.99. What is the ratio of the Unemployed and educated male labor force (% of population) in Tajikistan in 1999 to that in 2001?
Keep it short and to the point. 0.29. What is the ratio of the Unemployed and educated male labor force (% of population) of Turkey in 1999 to that in 2001?
Provide a succinct answer. 1.05. What is the ratio of the Unemployed and educated male labor force (% of population) of High income in 1999 to that in 2002?
Make the answer very short. 0.92. What is the ratio of the Unemployed and educated male labor force (% of population) in Colombia in 1999 to that in 2002?
Provide a succinct answer. 1.29. What is the ratio of the Unemployed and educated male labor force (% of population) of Tajikistan in 1999 to that in 2002?
Your answer should be very brief. 0.27. What is the ratio of the Unemployed and educated male labor force (% of population) of Turkey in 1999 to that in 2002?
Provide a short and direct response. 0.84. What is the ratio of the Unemployed and educated male labor force (% of population) in High income in 1999 to that in 2003?
Keep it short and to the point. 0.89. What is the ratio of the Unemployed and educated male labor force (% of population) in Colombia in 1999 to that in 2003?
Give a very brief answer. 1.14. What is the ratio of the Unemployed and educated male labor force (% of population) in Tajikistan in 1999 to that in 2003?
Give a very brief answer. 0.25. What is the ratio of the Unemployed and educated male labor force (% of population) of Turkey in 1999 to that in 2003?
Offer a terse response. 0.79. What is the ratio of the Unemployed and educated male labor force (% of population) of High income in 1999 to that in 2004?
Keep it short and to the point. 0.92. What is the ratio of the Unemployed and educated male labor force (% of population) in Tajikistan in 1999 to that in 2004?
Your answer should be very brief. 0.16. What is the ratio of the Unemployed and educated male labor force (% of population) in Turkey in 1999 to that in 2004?
Your response must be concise. 0.72. What is the ratio of the Unemployed and educated male labor force (% of population) of High income in 1999 to that in 2005?
Ensure brevity in your answer.  0.94. What is the ratio of the Unemployed and educated male labor force (% of population) of Colombia in 1999 to that in 2005?
Offer a very short reply. 0.95. What is the ratio of the Unemployed and educated male labor force (% of population) in Tajikistan in 1999 to that in 2005?
Make the answer very short. 0.29. What is the ratio of the Unemployed and educated male labor force (% of population) in Turkey in 1999 to that in 2005?
Ensure brevity in your answer.  0.81. What is the ratio of the Unemployed and educated male labor force (% of population) of Colombia in 2000 to that in 2001?
Your answer should be very brief. 1.74. What is the ratio of the Unemployed and educated male labor force (% of population) of Tajikistan in 2000 to that in 2001?
Make the answer very short. 0.98. What is the ratio of the Unemployed and educated male labor force (% of population) of Turkey in 2000 to that in 2001?
Provide a short and direct response. 1.14. What is the ratio of the Unemployed and educated male labor force (% of population) in High income in 2000 to that in 2002?
Your answer should be very brief. 0.92. What is the ratio of the Unemployed and educated male labor force (% of population) of Colombia in 2000 to that in 2002?
Ensure brevity in your answer.  1.68. What is the ratio of the Unemployed and educated male labor force (% of population) in Tajikistan in 2000 to that in 2002?
Your answer should be very brief. 0.92. What is the ratio of the Unemployed and educated male labor force (% of population) of Turkey in 2000 to that in 2002?
Your answer should be compact. 0.91. What is the ratio of the Unemployed and educated male labor force (% of population) in High income in 2000 to that in 2003?
Ensure brevity in your answer.  0.89. What is the ratio of the Unemployed and educated male labor force (% of population) in Colombia in 2000 to that in 2003?
Offer a terse response. 1.49. What is the ratio of the Unemployed and educated male labor force (% of population) in Tajikistan in 2000 to that in 2003?
Give a very brief answer. 0.86. What is the ratio of the Unemployed and educated male labor force (% of population) of High income in 2000 to that in 2004?
Your answer should be compact. 0.92. What is the ratio of the Unemployed and educated male labor force (% of population) in Colombia in 2000 to that in 2004?
Give a very brief answer. 1.43. What is the ratio of the Unemployed and educated male labor force (% of population) of Tajikistan in 2000 to that in 2004?
Keep it short and to the point. 0.53. What is the ratio of the Unemployed and educated male labor force (% of population) in Turkey in 2000 to that in 2004?
Your answer should be compact. 0.78. What is the ratio of the Unemployed and educated male labor force (% of population) in High income in 2000 to that in 2005?
Offer a terse response. 0.94. What is the ratio of the Unemployed and educated male labor force (% of population) in Colombia in 2000 to that in 2005?
Ensure brevity in your answer.  1.24. What is the ratio of the Unemployed and educated male labor force (% of population) of Tajikistan in 2000 to that in 2005?
Make the answer very short. 0.98. What is the ratio of the Unemployed and educated male labor force (% of population) of Turkey in 2000 to that in 2005?
Make the answer very short. 0.89. What is the ratio of the Unemployed and educated male labor force (% of population) in High income in 2001 to that in 2002?
Your answer should be very brief. 0.93. What is the ratio of the Unemployed and educated male labor force (% of population) in Colombia in 2001 to that in 2002?
Make the answer very short. 0.97. What is the ratio of the Unemployed and educated male labor force (% of population) in Turkey in 2001 to that in 2002?
Your answer should be very brief. 0.8. What is the ratio of the Unemployed and educated male labor force (% of population) in High income in 2001 to that in 2003?
Keep it short and to the point. 0.9. What is the ratio of the Unemployed and educated male labor force (% of population) in Colombia in 2001 to that in 2003?
Provide a short and direct response. 0.85. What is the ratio of the Unemployed and educated male labor force (% of population) in Tajikistan in 2001 to that in 2003?
Provide a succinct answer. 0.88. What is the ratio of the Unemployed and educated male labor force (% of population) in Turkey in 2001 to that in 2003?
Give a very brief answer. 0.75. What is the ratio of the Unemployed and educated male labor force (% of population) in High income in 2001 to that in 2004?
Your answer should be compact. 0.93. What is the ratio of the Unemployed and educated male labor force (% of population) of Colombia in 2001 to that in 2004?
Give a very brief answer. 0.82. What is the ratio of the Unemployed and educated male labor force (% of population) in Tajikistan in 2001 to that in 2004?
Keep it short and to the point. 0.54. What is the ratio of the Unemployed and educated male labor force (% of population) of Turkey in 2001 to that in 2004?
Provide a succinct answer. 0.68. What is the ratio of the Unemployed and educated male labor force (% of population) in High income in 2001 to that in 2005?
Give a very brief answer. 0.95. What is the ratio of the Unemployed and educated male labor force (% of population) in Colombia in 2001 to that in 2005?
Keep it short and to the point. 0.71. What is the ratio of the Unemployed and educated male labor force (% of population) in Tajikistan in 2001 to that in 2005?
Keep it short and to the point. 1. What is the ratio of the Unemployed and educated male labor force (% of population) in High income in 2002 to that in 2003?
Keep it short and to the point. 0.97. What is the ratio of the Unemployed and educated male labor force (% of population) in Colombia in 2002 to that in 2003?
Your answer should be compact. 0.88. What is the ratio of the Unemployed and educated male labor force (% of population) of Tajikistan in 2002 to that in 2003?
Ensure brevity in your answer.  0.94. What is the ratio of the Unemployed and educated male labor force (% of population) of Turkey in 2002 to that in 2003?
Ensure brevity in your answer.  0.94. What is the ratio of the Unemployed and educated male labor force (% of population) of Colombia in 2002 to that in 2004?
Offer a very short reply. 0.85. What is the ratio of the Unemployed and educated male labor force (% of population) in Tajikistan in 2002 to that in 2004?
Ensure brevity in your answer.  0.58. What is the ratio of the Unemployed and educated male labor force (% of population) of Turkey in 2002 to that in 2004?
Provide a short and direct response. 0.86. What is the ratio of the Unemployed and educated male labor force (% of population) in Colombia in 2002 to that in 2005?
Make the answer very short. 0.73. What is the ratio of the Unemployed and educated male labor force (% of population) in Tajikistan in 2002 to that in 2005?
Offer a very short reply. 1.07. What is the ratio of the Unemployed and educated male labor force (% of population) of Turkey in 2002 to that in 2005?
Your response must be concise. 0.98. What is the ratio of the Unemployed and educated male labor force (% of population) in High income in 2003 to that in 2004?
Keep it short and to the point. 1.03. What is the ratio of the Unemployed and educated male labor force (% of population) of Colombia in 2003 to that in 2004?
Your answer should be compact. 0.96. What is the ratio of the Unemployed and educated male labor force (% of population) of Tajikistan in 2003 to that in 2004?
Your answer should be very brief. 0.61. What is the ratio of the Unemployed and educated male labor force (% of population) in High income in 2003 to that in 2005?
Offer a very short reply. 1.05. What is the ratio of the Unemployed and educated male labor force (% of population) of Colombia in 2003 to that in 2005?
Keep it short and to the point. 0.83. What is the ratio of the Unemployed and educated male labor force (% of population) in Tajikistan in 2003 to that in 2005?
Your answer should be compact. 1.13. What is the ratio of the Unemployed and educated male labor force (% of population) of High income in 2004 to that in 2005?
Give a very brief answer. 1.02. What is the ratio of the Unemployed and educated male labor force (% of population) of Colombia in 2004 to that in 2005?
Make the answer very short. 0.87. What is the ratio of the Unemployed and educated male labor force (% of population) of Tajikistan in 2004 to that in 2005?
Ensure brevity in your answer.  1.84. What is the ratio of the Unemployed and educated male labor force (% of population) of Turkey in 2004 to that in 2005?
Your response must be concise. 1.14. What is the difference between the highest and the second highest Unemployed and educated male labor force (% of population) in High income?
Your response must be concise. 0.71. What is the difference between the highest and the second highest Unemployed and educated male labor force (% of population) in Colombia?
Provide a short and direct response. 4.8. What is the difference between the highest and the second highest Unemployed and educated male labor force (% of population) of Tajikistan?
Make the answer very short. 0.4. What is the difference between the highest and the second highest Unemployed and educated male labor force (% of population) in Turkey?
Provide a short and direct response. 0.8. What is the difference between the highest and the lowest Unemployed and educated male labor force (% of population) of High income?
Give a very brief answer. 3.03. What is the difference between the highest and the lowest Unemployed and educated male labor force (% of population) of Turkey?
Offer a very short reply. 2.9. 